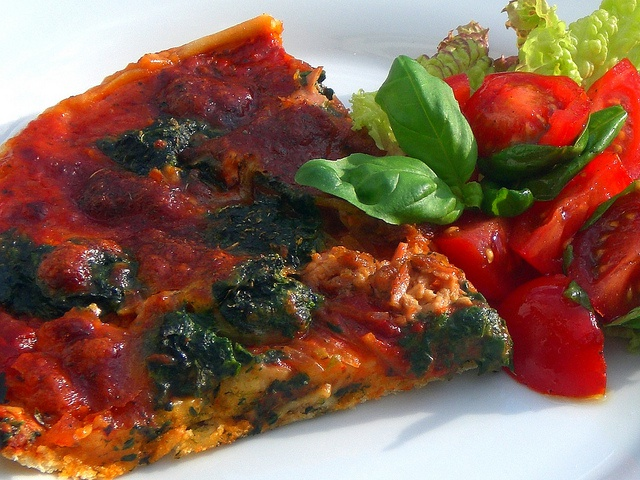Describe the objects in this image and their specific colors. I can see a pizza in white, maroon, black, and brown tones in this image. 